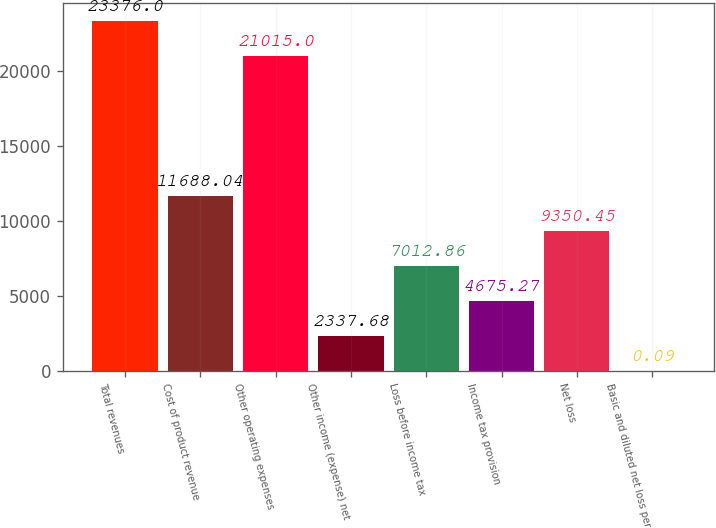<chart> <loc_0><loc_0><loc_500><loc_500><bar_chart><fcel>Total revenues<fcel>Cost of product revenue<fcel>Other operating expenses<fcel>Other income (expense) net<fcel>Loss before income tax<fcel>Income tax provision<fcel>Net loss<fcel>Basic and diluted net loss per<nl><fcel>23376<fcel>11688<fcel>21015<fcel>2337.68<fcel>7012.86<fcel>4675.27<fcel>9350.45<fcel>0.09<nl></chart> 